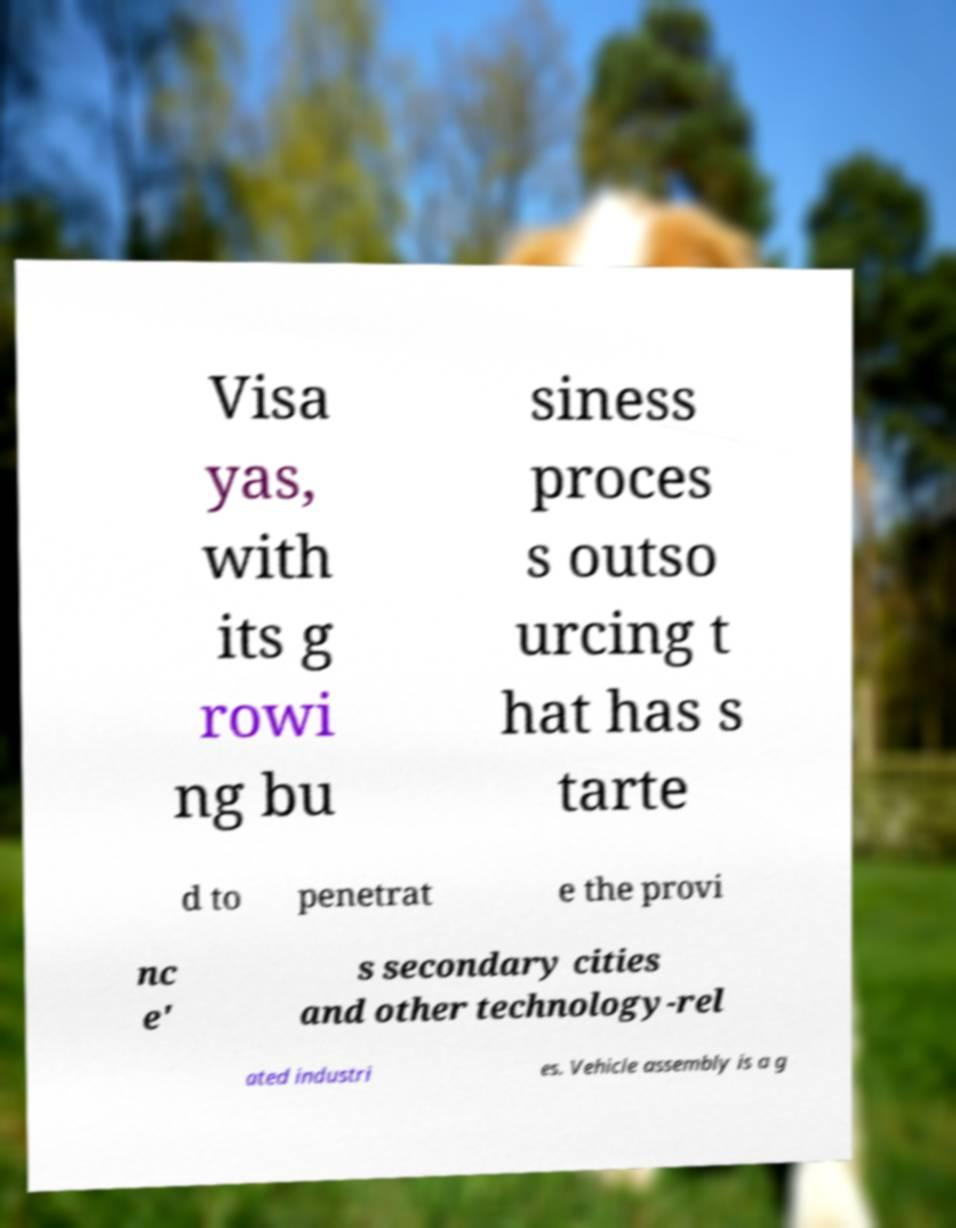Could you extract and type out the text from this image? Visa yas, with its g rowi ng bu siness proces s outso urcing t hat has s tarte d to penetrat e the provi nc e' s secondary cities and other technology-rel ated industri es. Vehicle assembly is a g 